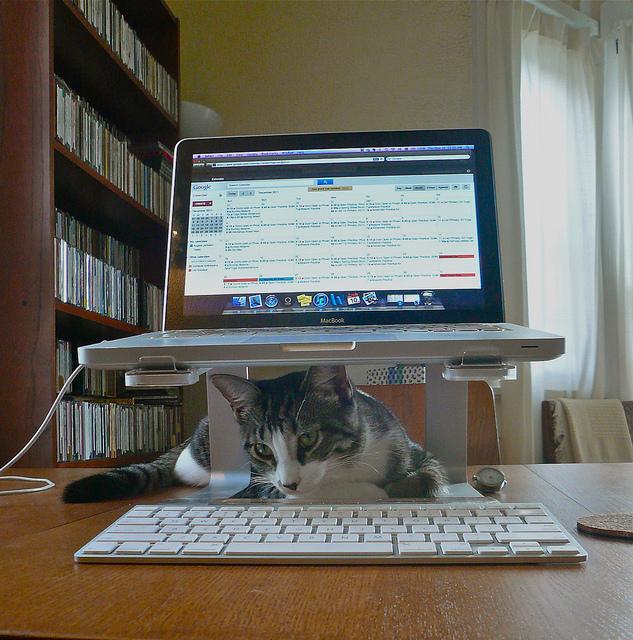Is there a mouse on the desk?
Short answer required. No. What is the cat doing?
Answer briefly. Laying. What is on the computer screen?
Be succinct. Calendar. Where is the window?
Give a very brief answer. On wall. Does the keyboard have non-English keys?
Give a very brief answer. No. What brand of computer is this?
Write a very short answer. Apple. Is the lamp turned on?
Write a very short answer. No. Has someone been eating pizza?
Answer briefly. No. 